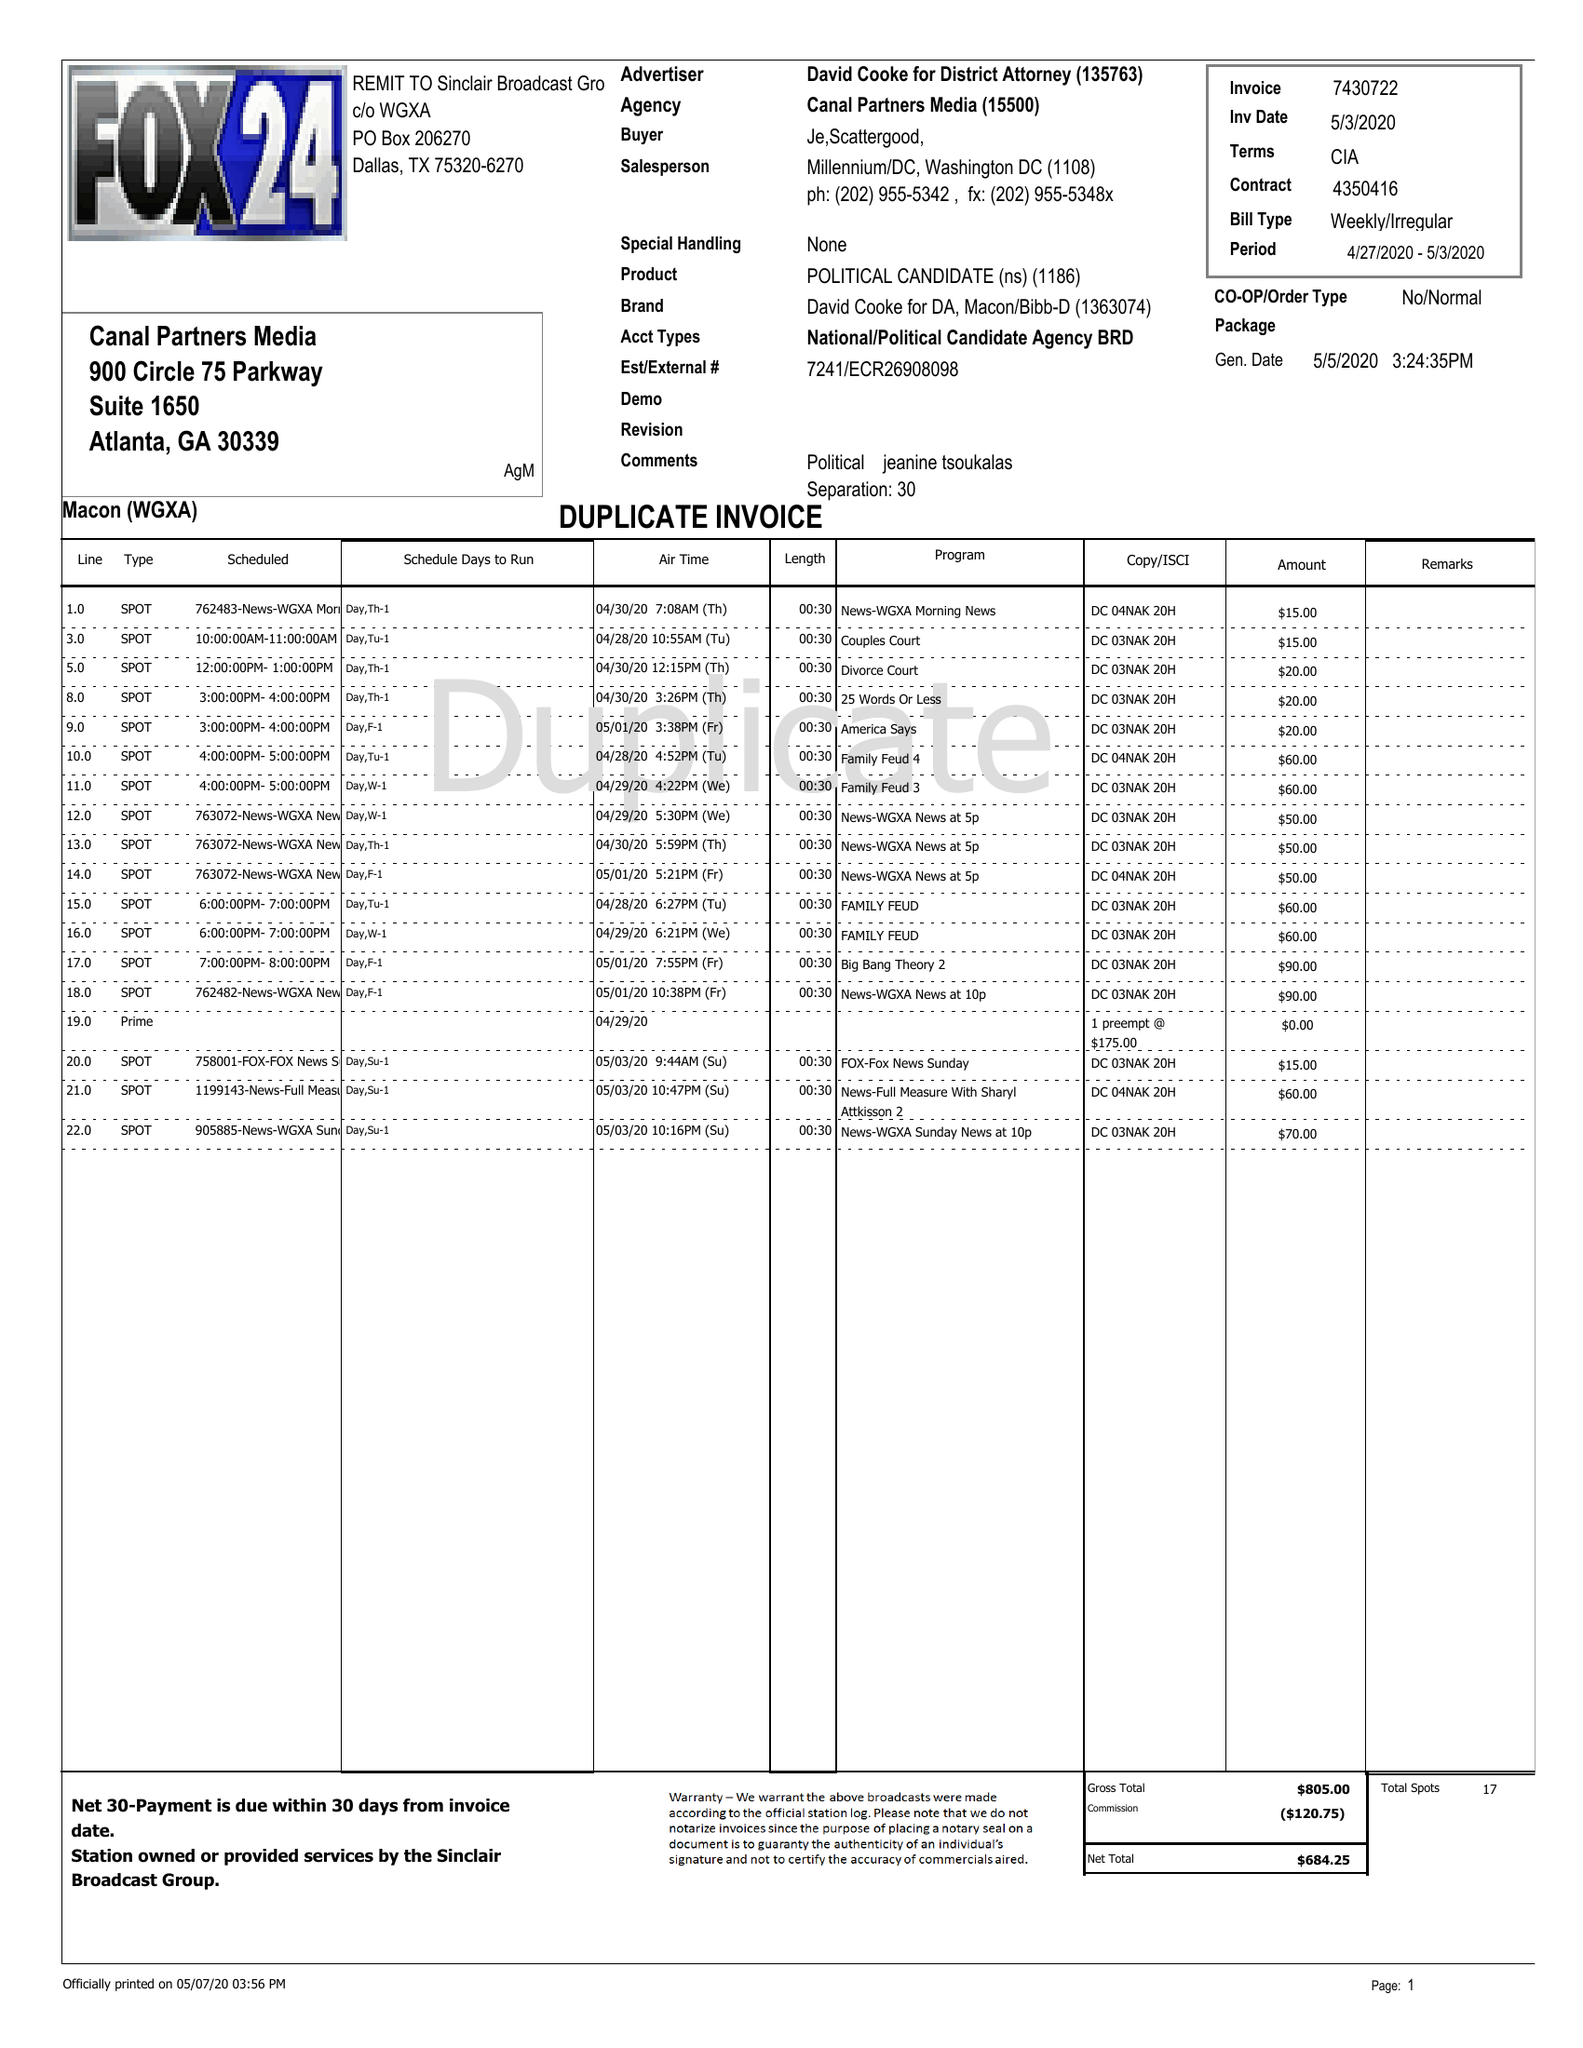What is the value for the flight_from?
Answer the question using a single word or phrase. 04/27/20 